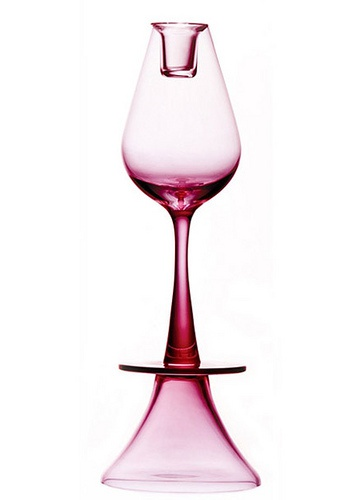Describe the objects in this image and their specific colors. I can see wine glass in white, black, maroon, and lightpink tones in this image. 